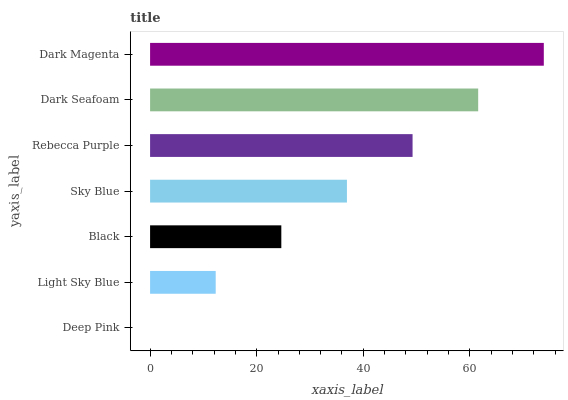Is Deep Pink the minimum?
Answer yes or no. Yes. Is Dark Magenta the maximum?
Answer yes or no. Yes. Is Light Sky Blue the minimum?
Answer yes or no. No. Is Light Sky Blue the maximum?
Answer yes or no. No. Is Light Sky Blue greater than Deep Pink?
Answer yes or no. Yes. Is Deep Pink less than Light Sky Blue?
Answer yes or no. Yes. Is Deep Pink greater than Light Sky Blue?
Answer yes or no. No. Is Light Sky Blue less than Deep Pink?
Answer yes or no. No. Is Sky Blue the high median?
Answer yes or no. Yes. Is Sky Blue the low median?
Answer yes or no. Yes. Is Deep Pink the high median?
Answer yes or no. No. Is Black the low median?
Answer yes or no. No. 